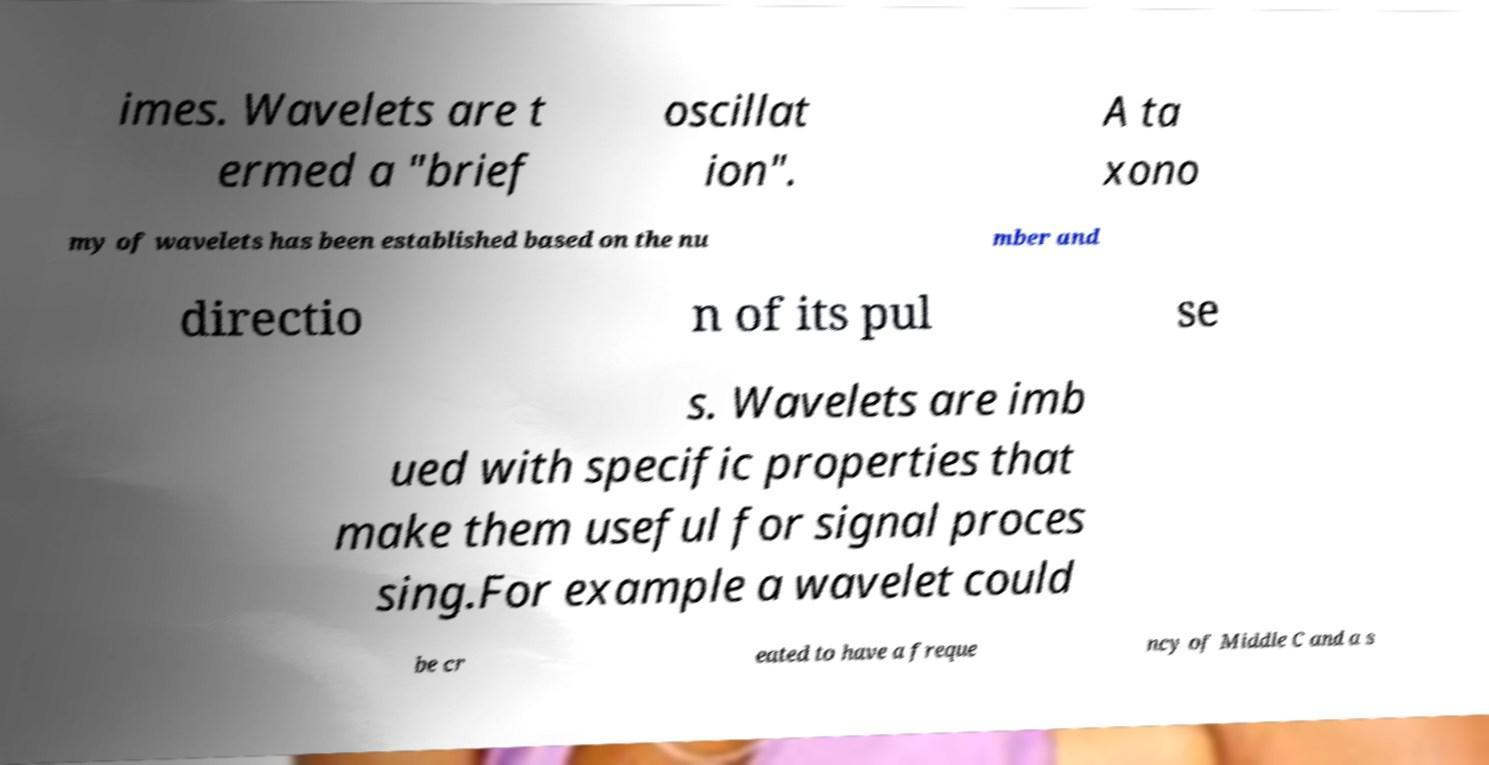I need the written content from this picture converted into text. Can you do that? imes. Wavelets are t ermed a "brief oscillat ion". A ta xono my of wavelets has been established based on the nu mber and directio n of its pul se s. Wavelets are imb ued with specific properties that make them useful for signal proces sing.For example a wavelet could be cr eated to have a freque ncy of Middle C and a s 